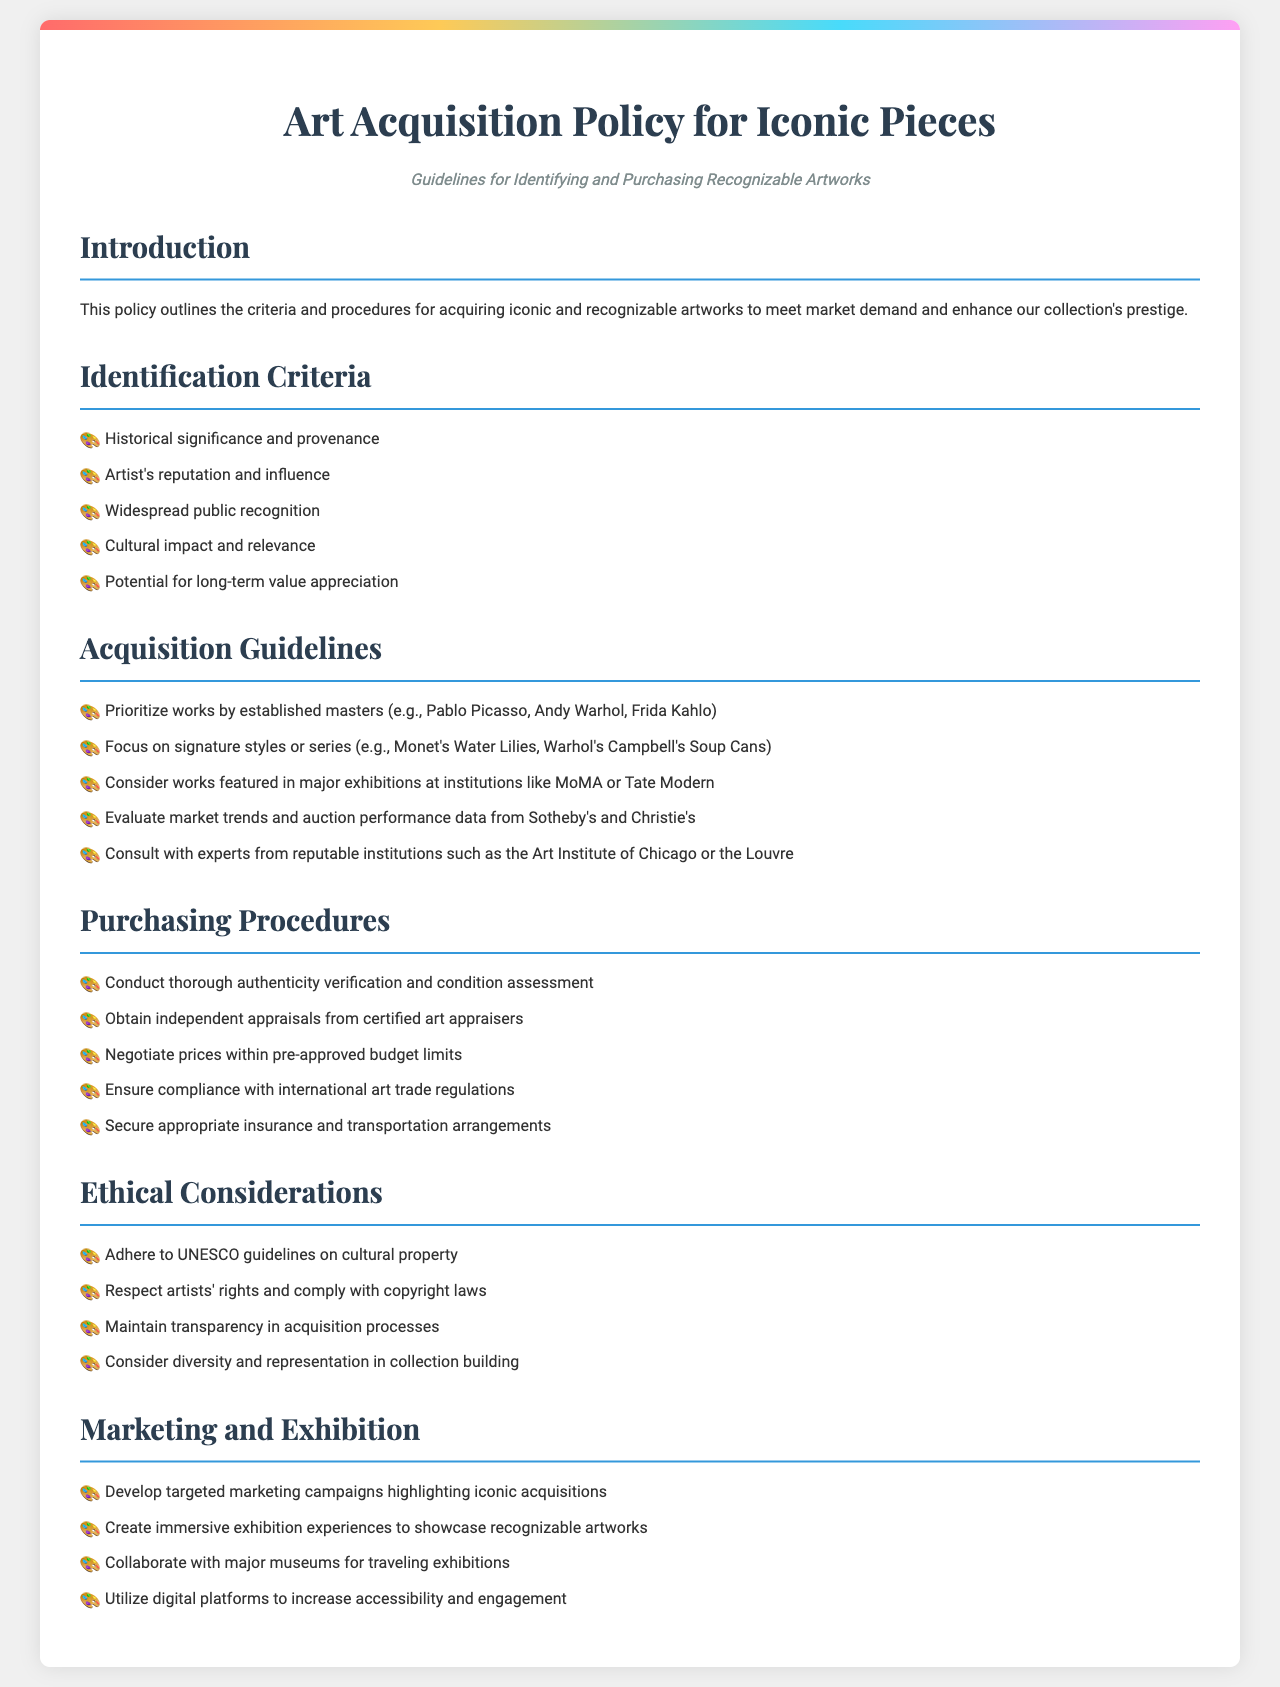What is the main goal of this policy? The main goal of the policy is to outline the criteria and procedures for acquiring iconic and recognizable artworks to meet market demand and enhance the collection's prestige.
Answer: Enhance collection's prestige What are the first two criteria for identifying artworks? The first two criteria for identifying artworks are historical significance and provenance, and the artist's reputation and influence.
Answer: Historical significance and provenance; Artist's reputation and influence Which artist's works are prioritized for acquisition? The policy prioritizes works by established masters, such as Pablo Picasso, Andy Warhol, and Frida Kahlo.
Answer: Pablo Picasso, Andy Warhol, Frida Kahlo What type of assessments are required before purchasing? Before purchasing, thorough authenticity verification and condition assessment are required.
Answer: Authenticity verification and condition assessment Which guidelines does the policy adhere to regarding cultural property? The policy adheres to UNESCO guidelines on cultural property.
Answer: UNESCO guidelines What is one type of marketing strategy mentioned in the document? One marketing strategy mentioned is to develop targeted marketing campaigns highlighting iconic acquisitions.
Answer: Targeted marketing campaigns How many total ethical considerations are listed? There are four ethical considerations listed in the document.
Answer: Four What does the policy suggest for consulting during acquisitions? The policy suggests consulting with experts from reputable institutions such as the Art Institute of Chicago or the Louvre.
Answer: Experts from reputable institutions What is the recommendation for insurance arrangements? The recommendation states to secure appropriate insurance and transportation arrangements.
Answer: Secure appropriate insurance and transportation arrangements 